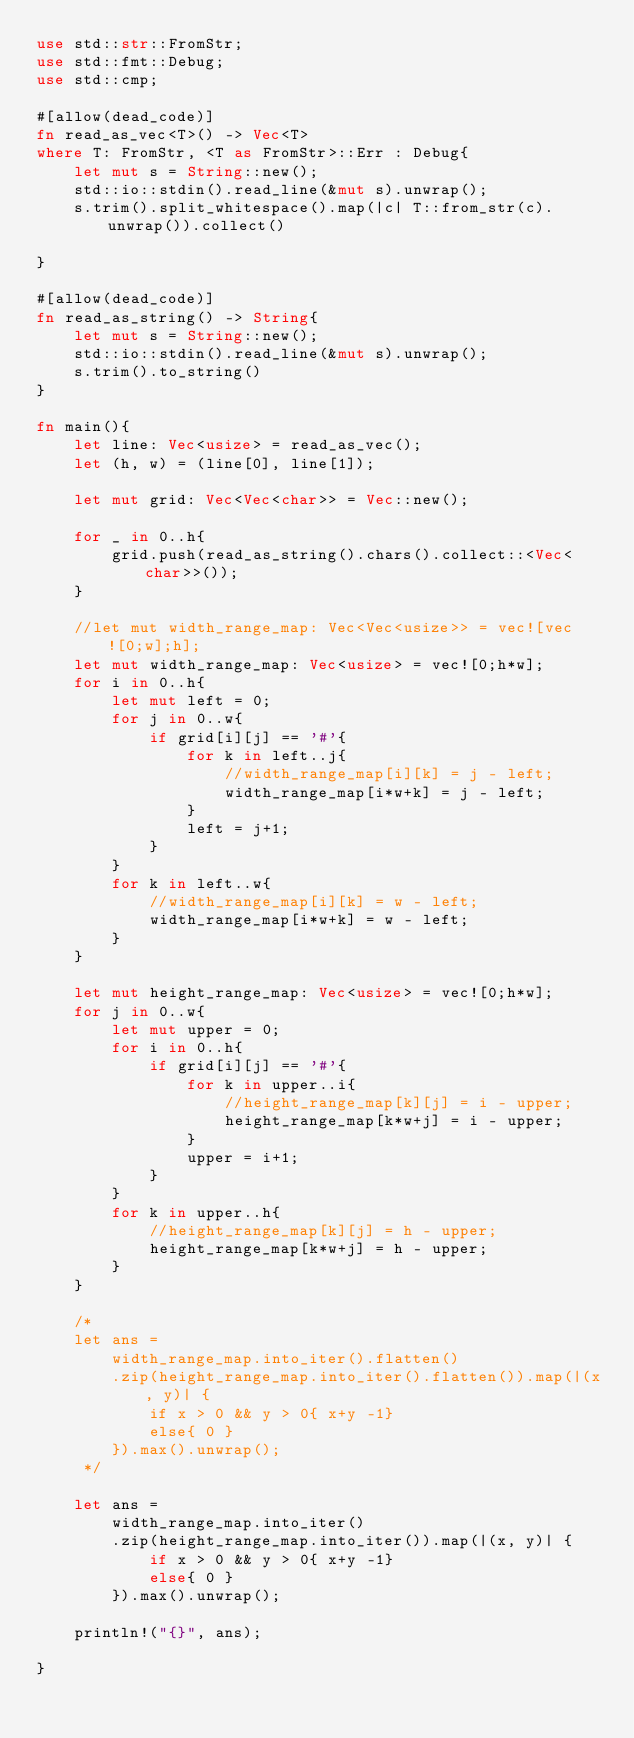Convert code to text. <code><loc_0><loc_0><loc_500><loc_500><_Rust_>use std::str::FromStr;
use std::fmt::Debug;
use std::cmp;

#[allow(dead_code)]
fn read_as_vec<T>() -> Vec<T>
where T: FromStr, <T as FromStr>::Err : Debug{
    let mut s = String::new();
    std::io::stdin().read_line(&mut s).unwrap();
    s.trim().split_whitespace().map(|c| T::from_str(c).unwrap()).collect()

}

#[allow(dead_code)]
fn read_as_string() -> String{
    let mut s = String::new();
    std::io::stdin().read_line(&mut s).unwrap();
    s.trim().to_string()
}

fn main(){
    let line: Vec<usize> = read_as_vec();
    let (h, w) = (line[0], line[1]);

    let mut grid: Vec<Vec<char>> = Vec::new();

    for _ in 0..h{
        grid.push(read_as_string().chars().collect::<Vec<char>>());
    }

    //let mut width_range_map: Vec<Vec<usize>> = vec![vec![0;w];h];
    let mut width_range_map: Vec<usize> = vec![0;h*w];
    for i in 0..h{
        let mut left = 0;
        for j in 0..w{
            if grid[i][j] == '#'{
                for k in left..j{
                    //width_range_map[i][k] = j - left;
                    width_range_map[i*w+k] = j - left;
                }
                left = j+1;
            }
        }
        for k in left..w{
            //width_range_map[i][k] = w - left;
            width_range_map[i*w+k] = w - left;
        }
    }

    let mut height_range_map: Vec<usize> = vec![0;h*w];
    for j in 0..w{
        let mut upper = 0;
        for i in 0..h{
            if grid[i][j] == '#'{
                for k in upper..i{
                    //height_range_map[k][j] = i - upper;
                    height_range_map[k*w+j] = i - upper;
                }
                upper = i+1;
            }
        }
        for k in upper..h{
            //height_range_map[k][j] = h - upper;
            height_range_map[k*w+j] = h - upper;
        }
    }

    /*
    let ans =
        width_range_map.into_iter().flatten()
        .zip(height_range_map.into_iter().flatten()).map(|(x, y)| {
            if x > 0 && y > 0{ x+y -1}
            else{ 0 }
        }).max().unwrap();
     */

    let ans =
        width_range_map.into_iter()
        .zip(height_range_map.into_iter()).map(|(x, y)| {
            if x > 0 && y > 0{ x+y -1}
            else{ 0 }
        }).max().unwrap();    

    println!("{}", ans);
    
}
</code> 